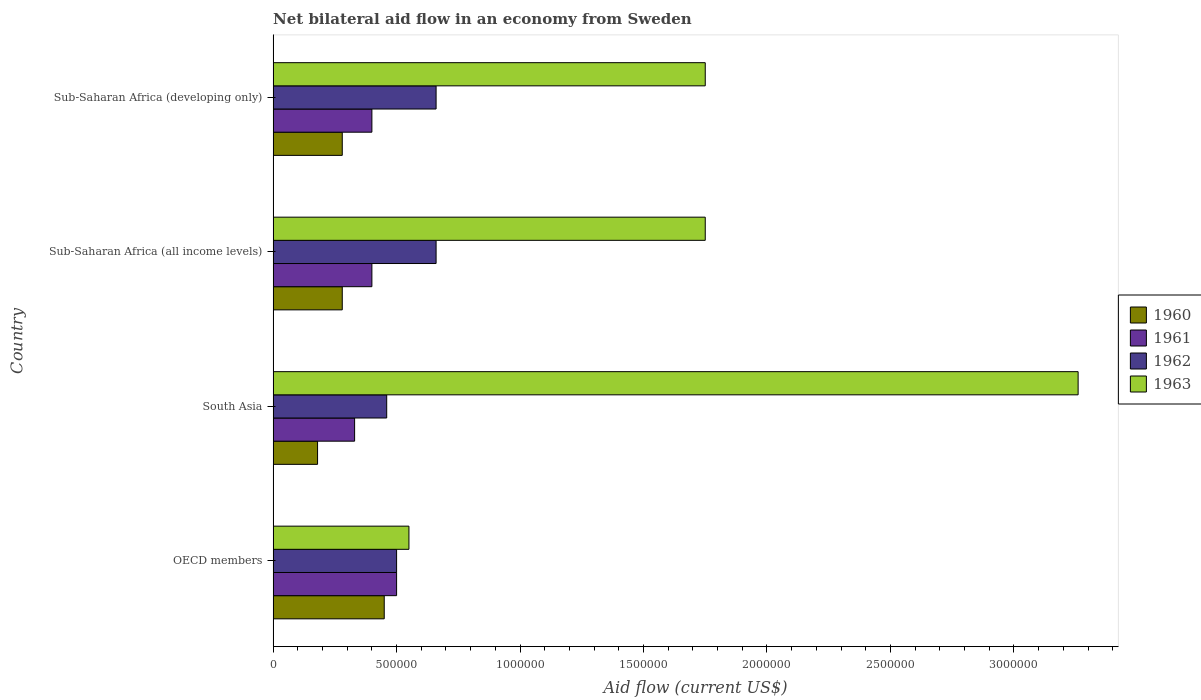How many different coloured bars are there?
Provide a succinct answer. 4. How many bars are there on the 4th tick from the bottom?
Provide a short and direct response. 4. What is the label of the 1st group of bars from the top?
Make the answer very short. Sub-Saharan Africa (developing only). In how many cases, is the number of bars for a given country not equal to the number of legend labels?
Offer a terse response. 0. Across all countries, what is the maximum net bilateral aid flow in 1960?
Make the answer very short. 4.50e+05. Across all countries, what is the minimum net bilateral aid flow in 1962?
Your answer should be very brief. 4.60e+05. In which country was the net bilateral aid flow in 1961 maximum?
Make the answer very short. OECD members. What is the total net bilateral aid flow in 1962 in the graph?
Provide a succinct answer. 2.28e+06. What is the difference between the net bilateral aid flow in 1962 in Sub-Saharan Africa (all income levels) and the net bilateral aid flow in 1963 in OECD members?
Your response must be concise. 1.10e+05. What is the average net bilateral aid flow in 1963 per country?
Your response must be concise. 1.83e+06. What is the difference between the net bilateral aid flow in 1960 and net bilateral aid flow in 1963 in OECD members?
Ensure brevity in your answer.  -1.00e+05. What is the ratio of the net bilateral aid flow in 1962 in OECD members to that in South Asia?
Your answer should be very brief. 1.09. What is the difference between the highest and the second highest net bilateral aid flow in 1960?
Make the answer very short. 1.70e+05. Is it the case that in every country, the sum of the net bilateral aid flow in 1961 and net bilateral aid flow in 1962 is greater than the sum of net bilateral aid flow in 1960 and net bilateral aid flow in 1963?
Make the answer very short. No. What does the 4th bar from the top in Sub-Saharan Africa (developing only) represents?
Provide a short and direct response. 1960. Is it the case that in every country, the sum of the net bilateral aid flow in 1960 and net bilateral aid flow in 1962 is greater than the net bilateral aid flow in 1963?
Provide a short and direct response. No. Are all the bars in the graph horizontal?
Provide a succinct answer. Yes. What is the difference between two consecutive major ticks on the X-axis?
Offer a very short reply. 5.00e+05. Are the values on the major ticks of X-axis written in scientific E-notation?
Ensure brevity in your answer.  No. Does the graph contain grids?
Your answer should be compact. No. Where does the legend appear in the graph?
Offer a very short reply. Center right. How many legend labels are there?
Your answer should be compact. 4. What is the title of the graph?
Your response must be concise. Net bilateral aid flow in an economy from Sweden. Does "1980" appear as one of the legend labels in the graph?
Offer a very short reply. No. What is the label or title of the X-axis?
Provide a short and direct response. Aid flow (current US$). What is the label or title of the Y-axis?
Your answer should be compact. Country. What is the Aid flow (current US$) of 1962 in OECD members?
Offer a terse response. 5.00e+05. What is the Aid flow (current US$) of 1963 in OECD members?
Your response must be concise. 5.50e+05. What is the Aid flow (current US$) of 1961 in South Asia?
Your answer should be compact. 3.30e+05. What is the Aid flow (current US$) in 1963 in South Asia?
Provide a succinct answer. 3.26e+06. What is the Aid flow (current US$) of 1961 in Sub-Saharan Africa (all income levels)?
Your response must be concise. 4.00e+05. What is the Aid flow (current US$) of 1963 in Sub-Saharan Africa (all income levels)?
Offer a very short reply. 1.75e+06. What is the Aid flow (current US$) in 1960 in Sub-Saharan Africa (developing only)?
Your answer should be compact. 2.80e+05. What is the Aid flow (current US$) in 1961 in Sub-Saharan Africa (developing only)?
Give a very brief answer. 4.00e+05. What is the Aid flow (current US$) in 1963 in Sub-Saharan Africa (developing only)?
Your answer should be compact. 1.75e+06. Across all countries, what is the maximum Aid flow (current US$) of 1960?
Keep it short and to the point. 4.50e+05. Across all countries, what is the maximum Aid flow (current US$) of 1962?
Give a very brief answer. 6.60e+05. Across all countries, what is the maximum Aid flow (current US$) in 1963?
Keep it short and to the point. 3.26e+06. Across all countries, what is the minimum Aid flow (current US$) in 1961?
Provide a succinct answer. 3.30e+05. What is the total Aid flow (current US$) of 1960 in the graph?
Your answer should be very brief. 1.19e+06. What is the total Aid flow (current US$) in 1961 in the graph?
Make the answer very short. 1.63e+06. What is the total Aid flow (current US$) of 1962 in the graph?
Provide a short and direct response. 2.28e+06. What is the total Aid flow (current US$) of 1963 in the graph?
Your response must be concise. 7.31e+06. What is the difference between the Aid flow (current US$) in 1963 in OECD members and that in South Asia?
Provide a short and direct response. -2.71e+06. What is the difference between the Aid flow (current US$) of 1962 in OECD members and that in Sub-Saharan Africa (all income levels)?
Provide a short and direct response. -1.60e+05. What is the difference between the Aid flow (current US$) in 1963 in OECD members and that in Sub-Saharan Africa (all income levels)?
Give a very brief answer. -1.20e+06. What is the difference between the Aid flow (current US$) of 1960 in OECD members and that in Sub-Saharan Africa (developing only)?
Provide a short and direct response. 1.70e+05. What is the difference between the Aid flow (current US$) of 1962 in OECD members and that in Sub-Saharan Africa (developing only)?
Keep it short and to the point. -1.60e+05. What is the difference between the Aid flow (current US$) in 1963 in OECD members and that in Sub-Saharan Africa (developing only)?
Your response must be concise. -1.20e+06. What is the difference between the Aid flow (current US$) of 1960 in South Asia and that in Sub-Saharan Africa (all income levels)?
Give a very brief answer. -1.00e+05. What is the difference between the Aid flow (current US$) of 1961 in South Asia and that in Sub-Saharan Africa (all income levels)?
Make the answer very short. -7.00e+04. What is the difference between the Aid flow (current US$) of 1962 in South Asia and that in Sub-Saharan Africa (all income levels)?
Ensure brevity in your answer.  -2.00e+05. What is the difference between the Aid flow (current US$) in 1963 in South Asia and that in Sub-Saharan Africa (all income levels)?
Offer a terse response. 1.51e+06. What is the difference between the Aid flow (current US$) in 1960 in South Asia and that in Sub-Saharan Africa (developing only)?
Ensure brevity in your answer.  -1.00e+05. What is the difference between the Aid flow (current US$) in 1961 in South Asia and that in Sub-Saharan Africa (developing only)?
Give a very brief answer. -7.00e+04. What is the difference between the Aid flow (current US$) in 1962 in South Asia and that in Sub-Saharan Africa (developing only)?
Keep it short and to the point. -2.00e+05. What is the difference between the Aid flow (current US$) of 1963 in South Asia and that in Sub-Saharan Africa (developing only)?
Offer a terse response. 1.51e+06. What is the difference between the Aid flow (current US$) in 1960 in Sub-Saharan Africa (all income levels) and that in Sub-Saharan Africa (developing only)?
Offer a very short reply. 0. What is the difference between the Aid flow (current US$) of 1963 in Sub-Saharan Africa (all income levels) and that in Sub-Saharan Africa (developing only)?
Make the answer very short. 0. What is the difference between the Aid flow (current US$) of 1960 in OECD members and the Aid flow (current US$) of 1963 in South Asia?
Offer a very short reply. -2.81e+06. What is the difference between the Aid flow (current US$) of 1961 in OECD members and the Aid flow (current US$) of 1963 in South Asia?
Your response must be concise. -2.76e+06. What is the difference between the Aid flow (current US$) of 1962 in OECD members and the Aid flow (current US$) of 1963 in South Asia?
Your answer should be compact. -2.76e+06. What is the difference between the Aid flow (current US$) in 1960 in OECD members and the Aid flow (current US$) in 1961 in Sub-Saharan Africa (all income levels)?
Make the answer very short. 5.00e+04. What is the difference between the Aid flow (current US$) in 1960 in OECD members and the Aid flow (current US$) in 1962 in Sub-Saharan Africa (all income levels)?
Your response must be concise. -2.10e+05. What is the difference between the Aid flow (current US$) in 1960 in OECD members and the Aid flow (current US$) in 1963 in Sub-Saharan Africa (all income levels)?
Offer a very short reply. -1.30e+06. What is the difference between the Aid flow (current US$) of 1961 in OECD members and the Aid flow (current US$) of 1962 in Sub-Saharan Africa (all income levels)?
Make the answer very short. -1.60e+05. What is the difference between the Aid flow (current US$) of 1961 in OECD members and the Aid flow (current US$) of 1963 in Sub-Saharan Africa (all income levels)?
Offer a terse response. -1.25e+06. What is the difference between the Aid flow (current US$) of 1962 in OECD members and the Aid flow (current US$) of 1963 in Sub-Saharan Africa (all income levels)?
Offer a terse response. -1.25e+06. What is the difference between the Aid flow (current US$) of 1960 in OECD members and the Aid flow (current US$) of 1961 in Sub-Saharan Africa (developing only)?
Keep it short and to the point. 5.00e+04. What is the difference between the Aid flow (current US$) in 1960 in OECD members and the Aid flow (current US$) in 1963 in Sub-Saharan Africa (developing only)?
Ensure brevity in your answer.  -1.30e+06. What is the difference between the Aid flow (current US$) in 1961 in OECD members and the Aid flow (current US$) in 1963 in Sub-Saharan Africa (developing only)?
Ensure brevity in your answer.  -1.25e+06. What is the difference between the Aid flow (current US$) of 1962 in OECD members and the Aid flow (current US$) of 1963 in Sub-Saharan Africa (developing only)?
Ensure brevity in your answer.  -1.25e+06. What is the difference between the Aid flow (current US$) of 1960 in South Asia and the Aid flow (current US$) of 1961 in Sub-Saharan Africa (all income levels)?
Your answer should be compact. -2.20e+05. What is the difference between the Aid flow (current US$) in 1960 in South Asia and the Aid flow (current US$) in 1962 in Sub-Saharan Africa (all income levels)?
Make the answer very short. -4.80e+05. What is the difference between the Aid flow (current US$) of 1960 in South Asia and the Aid flow (current US$) of 1963 in Sub-Saharan Africa (all income levels)?
Offer a very short reply. -1.57e+06. What is the difference between the Aid flow (current US$) of 1961 in South Asia and the Aid flow (current US$) of 1962 in Sub-Saharan Africa (all income levels)?
Ensure brevity in your answer.  -3.30e+05. What is the difference between the Aid flow (current US$) in 1961 in South Asia and the Aid flow (current US$) in 1963 in Sub-Saharan Africa (all income levels)?
Offer a very short reply. -1.42e+06. What is the difference between the Aid flow (current US$) in 1962 in South Asia and the Aid flow (current US$) in 1963 in Sub-Saharan Africa (all income levels)?
Provide a succinct answer. -1.29e+06. What is the difference between the Aid flow (current US$) in 1960 in South Asia and the Aid flow (current US$) in 1962 in Sub-Saharan Africa (developing only)?
Your response must be concise. -4.80e+05. What is the difference between the Aid flow (current US$) in 1960 in South Asia and the Aid flow (current US$) in 1963 in Sub-Saharan Africa (developing only)?
Give a very brief answer. -1.57e+06. What is the difference between the Aid flow (current US$) of 1961 in South Asia and the Aid flow (current US$) of 1962 in Sub-Saharan Africa (developing only)?
Give a very brief answer. -3.30e+05. What is the difference between the Aid flow (current US$) of 1961 in South Asia and the Aid flow (current US$) of 1963 in Sub-Saharan Africa (developing only)?
Ensure brevity in your answer.  -1.42e+06. What is the difference between the Aid flow (current US$) in 1962 in South Asia and the Aid flow (current US$) in 1963 in Sub-Saharan Africa (developing only)?
Your answer should be very brief. -1.29e+06. What is the difference between the Aid flow (current US$) of 1960 in Sub-Saharan Africa (all income levels) and the Aid flow (current US$) of 1962 in Sub-Saharan Africa (developing only)?
Your answer should be compact. -3.80e+05. What is the difference between the Aid flow (current US$) in 1960 in Sub-Saharan Africa (all income levels) and the Aid flow (current US$) in 1963 in Sub-Saharan Africa (developing only)?
Make the answer very short. -1.47e+06. What is the difference between the Aid flow (current US$) in 1961 in Sub-Saharan Africa (all income levels) and the Aid flow (current US$) in 1963 in Sub-Saharan Africa (developing only)?
Your answer should be very brief. -1.35e+06. What is the difference between the Aid flow (current US$) in 1962 in Sub-Saharan Africa (all income levels) and the Aid flow (current US$) in 1963 in Sub-Saharan Africa (developing only)?
Provide a short and direct response. -1.09e+06. What is the average Aid flow (current US$) in 1960 per country?
Provide a short and direct response. 2.98e+05. What is the average Aid flow (current US$) of 1961 per country?
Provide a short and direct response. 4.08e+05. What is the average Aid flow (current US$) of 1962 per country?
Your answer should be compact. 5.70e+05. What is the average Aid flow (current US$) of 1963 per country?
Offer a terse response. 1.83e+06. What is the difference between the Aid flow (current US$) in 1960 and Aid flow (current US$) in 1961 in OECD members?
Give a very brief answer. -5.00e+04. What is the difference between the Aid flow (current US$) in 1960 and Aid flow (current US$) in 1962 in OECD members?
Provide a succinct answer. -5.00e+04. What is the difference between the Aid flow (current US$) of 1960 and Aid flow (current US$) of 1963 in OECD members?
Provide a short and direct response. -1.00e+05. What is the difference between the Aid flow (current US$) in 1961 and Aid flow (current US$) in 1962 in OECD members?
Keep it short and to the point. 0. What is the difference between the Aid flow (current US$) of 1961 and Aid flow (current US$) of 1963 in OECD members?
Make the answer very short. -5.00e+04. What is the difference between the Aid flow (current US$) in 1962 and Aid flow (current US$) in 1963 in OECD members?
Offer a terse response. -5.00e+04. What is the difference between the Aid flow (current US$) in 1960 and Aid flow (current US$) in 1962 in South Asia?
Ensure brevity in your answer.  -2.80e+05. What is the difference between the Aid flow (current US$) in 1960 and Aid flow (current US$) in 1963 in South Asia?
Keep it short and to the point. -3.08e+06. What is the difference between the Aid flow (current US$) in 1961 and Aid flow (current US$) in 1962 in South Asia?
Provide a succinct answer. -1.30e+05. What is the difference between the Aid flow (current US$) in 1961 and Aid flow (current US$) in 1963 in South Asia?
Provide a succinct answer. -2.93e+06. What is the difference between the Aid flow (current US$) of 1962 and Aid flow (current US$) of 1963 in South Asia?
Your answer should be compact. -2.80e+06. What is the difference between the Aid flow (current US$) of 1960 and Aid flow (current US$) of 1962 in Sub-Saharan Africa (all income levels)?
Provide a short and direct response. -3.80e+05. What is the difference between the Aid flow (current US$) in 1960 and Aid flow (current US$) in 1963 in Sub-Saharan Africa (all income levels)?
Give a very brief answer. -1.47e+06. What is the difference between the Aid flow (current US$) in 1961 and Aid flow (current US$) in 1962 in Sub-Saharan Africa (all income levels)?
Give a very brief answer. -2.60e+05. What is the difference between the Aid flow (current US$) in 1961 and Aid flow (current US$) in 1963 in Sub-Saharan Africa (all income levels)?
Keep it short and to the point. -1.35e+06. What is the difference between the Aid flow (current US$) of 1962 and Aid flow (current US$) of 1963 in Sub-Saharan Africa (all income levels)?
Offer a very short reply. -1.09e+06. What is the difference between the Aid flow (current US$) of 1960 and Aid flow (current US$) of 1961 in Sub-Saharan Africa (developing only)?
Offer a terse response. -1.20e+05. What is the difference between the Aid flow (current US$) of 1960 and Aid flow (current US$) of 1962 in Sub-Saharan Africa (developing only)?
Your answer should be compact. -3.80e+05. What is the difference between the Aid flow (current US$) in 1960 and Aid flow (current US$) in 1963 in Sub-Saharan Africa (developing only)?
Your answer should be compact. -1.47e+06. What is the difference between the Aid flow (current US$) of 1961 and Aid flow (current US$) of 1963 in Sub-Saharan Africa (developing only)?
Offer a very short reply. -1.35e+06. What is the difference between the Aid flow (current US$) of 1962 and Aid flow (current US$) of 1963 in Sub-Saharan Africa (developing only)?
Offer a terse response. -1.09e+06. What is the ratio of the Aid flow (current US$) in 1960 in OECD members to that in South Asia?
Your answer should be very brief. 2.5. What is the ratio of the Aid flow (current US$) of 1961 in OECD members to that in South Asia?
Keep it short and to the point. 1.52. What is the ratio of the Aid flow (current US$) of 1962 in OECD members to that in South Asia?
Provide a succinct answer. 1.09. What is the ratio of the Aid flow (current US$) of 1963 in OECD members to that in South Asia?
Provide a succinct answer. 0.17. What is the ratio of the Aid flow (current US$) of 1960 in OECD members to that in Sub-Saharan Africa (all income levels)?
Your response must be concise. 1.61. What is the ratio of the Aid flow (current US$) of 1962 in OECD members to that in Sub-Saharan Africa (all income levels)?
Ensure brevity in your answer.  0.76. What is the ratio of the Aid flow (current US$) in 1963 in OECD members to that in Sub-Saharan Africa (all income levels)?
Keep it short and to the point. 0.31. What is the ratio of the Aid flow (current US$) of 1960 in OECD members to that in Sub-Saharan Africa (developing only)?
Offer a very short reply. 1.61. What is the ratio of the Aid flow (current US$) of 1962 in OECD members to that in Sub-Saharan Africa (developing only)?
Your answer should be very brief. 0.76. What is the ratio of the Aid flow (current US$) of 1963 in OECD members to that in Sub-Saharan Africa (developing only)?
Provide a short and direct response. 0.31. What is the ratio of the Aid flow (current US$) in 1960 in South Asia to that in Sub-Saharan Africa (all income levels)?
Your answer should be compact. 0.64. What is the ratio of the Aid flow (current US$) in 1961 in South Asia to that in Sub-Saharan Africa (all income levels)?
Your response must be concise. 0.82. What is the ratio of the Aid flow (current US$) of 1962 in South Asia to that in Sub-Saharan Africa (all income levels)?
Provide a succinct answer. 0.7. What is the ratio of the Aid flow (current US$) in 1963 in South Asia to that in Sub-Saharan Africa (all income levels)?
Ensure brevity in your answer.  1.86. What is the ratio of the Aid flow (current US$) of 1960 in South Asia to that in Sub-Saharan Africa (developing only)?
Offer a very short reply. 0.64. What is the ratio of the Aid flow (current US$) in 1961 in South Asia to that in Sub-Saharan Africa (developing only)?
Give a very brief answer. 0.82. What is the ratio of the Aid flow (current US$) in 1962 in South Asia to that in Sub-Saharan Africa (developing only)?
Your answer should be compact. 0.7. What is the ratio of the Aid flow (current US$) in 1963 in South Asia to that in Sub-Saharan Africa (developing only)?
Your answer should be very brief. 1.86. What is the ratio of the Aid flow (current US$) of 1961 in Sub-Saharan Africa (all income levels) to that in Sub-Saharan Africa (developing only)?
Keep it short and to the point. 1. What is the ratio of the Aid flow (current US$) of 1963 in Sub-Saharan Africa (all income levels) to that in Sub-Saharan Africa (developing only)?
Your answer should be compact. 1. What is the difference between the highest and the second highest Aid flow (current US$) in 1960?
Offer a terse response. 1.70e+05. What is the difference between the highest and the second highest Aid flow (current US$) in 1961?
Provide a succinct answer. 1.00e+05. What is the difference between the highest and the second highest Aid flow (current US$) of 1963?
Your answer should be compact. 1.51e+06. What is the difference between the highest and the lowest Aid flow (current US$) of 1960?
Keep it short and to the point. 2.70e+05. What is the difference between the highest and the lowest Aid flow (current US$) of 1962?
Ensure brevity in your answer.  2.00e+05. What is the difference between the highest and the lowest Aid flow (current US$) in 1963?
Make the answer very short. 2.71e+06. 